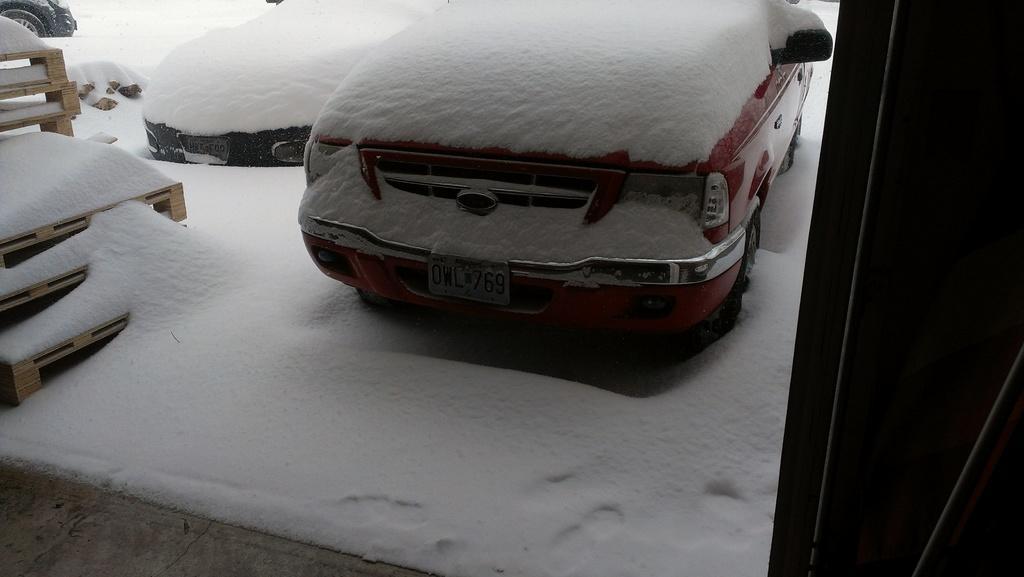Could you give a brief overview of what you see in this image? In this image we can see a few vehicles covered with the snow, on the left side of the image we can see an object, which looks like a staircase and right side of the image is dark. 